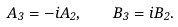<formula> <loc_0><loc_0><loc_500><loc_500>A _ { 3 } = - i A _ { 2 } , \quad B _ { 3 } = i B _ { 2 } .</formula> 